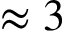Convert formula to latex. <formula><loc_0><loc_0><loc_500><loc_500>\approx 3</formula> 